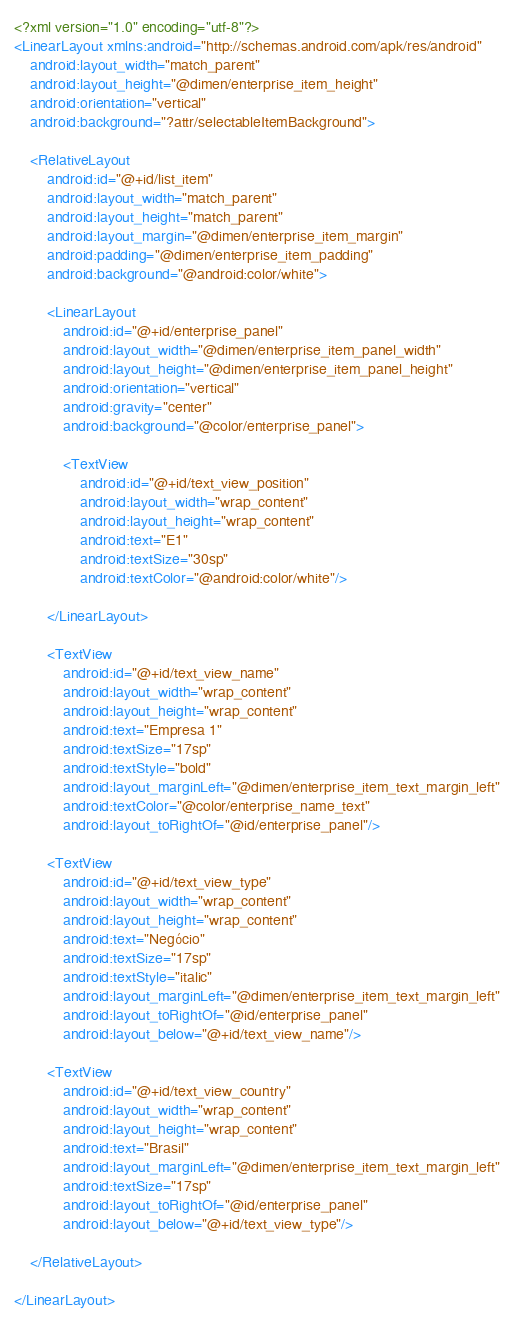<code> <loc_0><loc_0><loc_500><loc_500><_XML_><?xml version="1.0" encoding="utf-8"?>
<LinearLayout xmlns:android="http://schemas.android.com/apk/res/android"
    android:layout_width="match_parent"
    android:layout_height="@dimen/enterprise_item_height"
    android:orientation="vertical"
    android:background="?attr/selectableItemBackground">

    <RelativeLayout
        android:id="@+id/list_item"
        android:layout_width="match_parent"
        android:layout_height="match_parent"
        android:layout_margin="@dimen/enterprise_item_margin"
        android:padding="@dimen/enterprise_item_padding"
        android:background="@android:color/white">
        
        <LinearLayout
            android:id="@+id/enterprise_panel"
            android:layout_width="@dimen/enterprise_item_panel_width"
            android:layout_height="@dimen/enterprise_item_panel_height"
            android:orientation="vertical"
            android:gravity="center"
            android:background="@color/enterprise_panel">

            <TextView
                android:id="@+id/text_view_position"
                android:layout_width="wrap_content"
                android:layout_height="wrap_content"
                android:text="E1"
                android:textSize="30sp"
                android:textColor="@android:color/white"/>

        </LinearLayout>

        <TextView
            android:id="@+id/text_view_name"
            android:layout_width="wrap_content"
            android:layout_height="wrap_content"
            android:text="Empresa 1"
            android:textSize="17sp"
            android:textStyle="bold"
            android:layout_marginLeft="@dimen/enterprise_item_text_margin_left"
            android:textColor="@color/enterprise_name_text"
            android:layout_toRightOf="@id/enterprise_panel"/>

        <TextView
            android:id="@+id/text_view_type"
            android:layout_width="wrap_content"
            android:layout_height="wrap_content"
            android:text="Negócio"
            android:textSize="17sp"
            android:textStyle="italic"
            android:layout_marginLeft="@dimen/enterprise_item_text_margin_left"
            android:layout_toRightOf="@id/enterprise_panel"
            android:layout_below="@+id/text_view_name"/>

        <TextView
            android:id="@+id/text_view_country"
            android:layout_width="wrap_content"
            android:layout_height="wrap_content"
            android:text="Brasil"
            android:layout_marginLeft="@dimen/enterprise_item_text_margin_left"
            android:textSize="17sp"
            android:layout_toRightOf="@id/enterprise_panel"
            android:layout_below="@+id/text_view_type"/>

    </RelativeLayout>

</LinearLayout></code> 